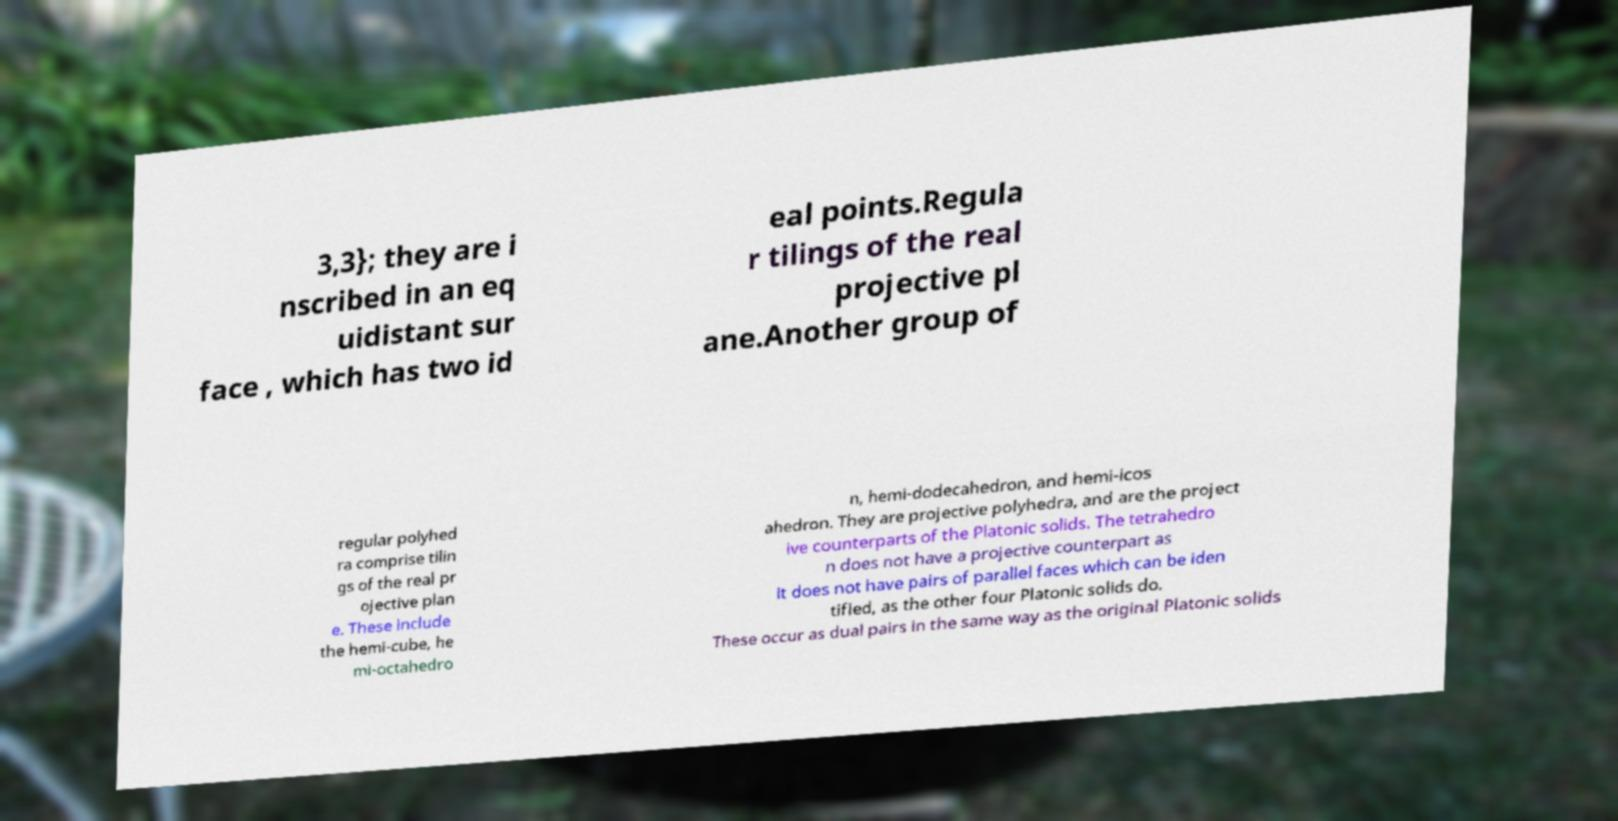What messages or text are displayed in this image? I need them in a readable, typed format. 3,3}; they are i nscribed in an eq uidistant sur face , which has two id eal points.Regula r tilings of the real projective pl ane.Another group of regular polyhed ra comprise tilin gs of the real pr ojective plan e. These include the hemi-cube, he mi-octahedro n, hemi-dodecahedron, and hemi-icos ahedron. They are projective polyhedra, and are the project ive counterparts of the Platonic solids. The tetrahedro n does not have a projective counterpart as it does not have pairs of parallel faces which can be iden tified, as the other four Platonic solids do. These occur as dual pairs in the same way as the original Platonic solids 